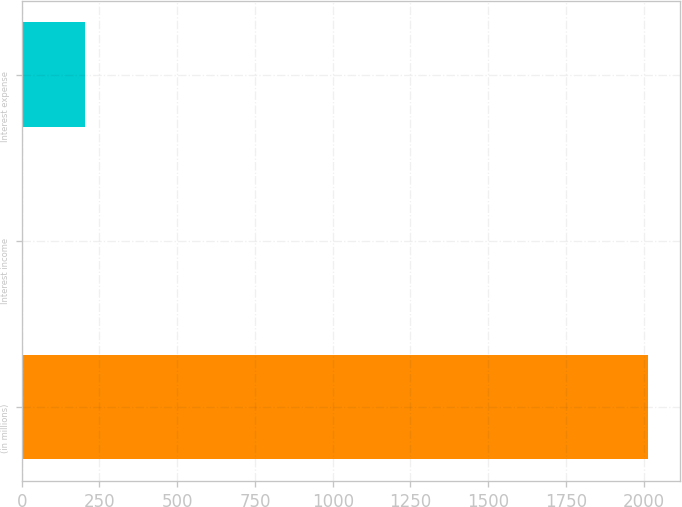Convert chart. <chart><loc_0><loc_0><loc_500><loc_500><bar_chart><fcel>(in millions)<fcel>Interest income<fcel>Interest expense<nl><fcel>2015<fcel>4<fcel>205.1<nl></chart> 